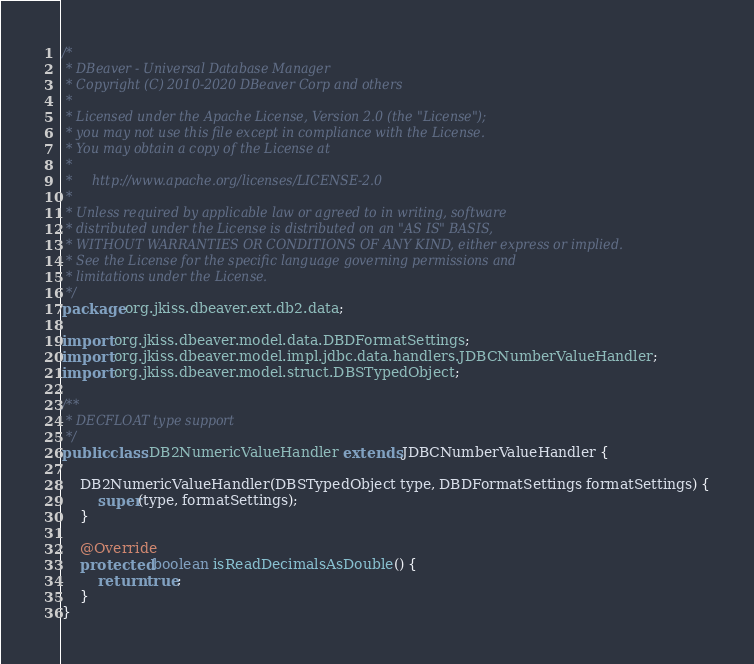Convert code to text. <code><loc_0><loc_0><loc_500><loc_500><_Java_>/*
 * DBeaver - Universal Database Manager
 * Copyright (C) 2010-2020 DBeaver Corp and others
 *
 * Licensed under the Apache License, Version 2.0 (the "License");
 * you may not use this file except in compliance with the License.
 * You may obtain a copy of the License at
 *
 *     http://www.apache.org/licenses/LICENSE-2.0
 *
 * Unless required by applicable law or agreed to in writing, software
 * distributed under the License is distributed on an "AS IS" BASIS,
 * WITHOUT WARRANTIES OR CONDITIONS OF ANY KIND, either express or implied.
 * See the License for the specific language governing permissions and
 * limitations under the License.
 */
package org.jkiss.dbeaver.ext.db2.data;

import org.jkiss.dbeaver.model.data.DBDFormatSettings;
import org.jkiss.dbeaver.model.impl.jdbc.data.handlers.JDBCNumberValueHandler;
import org.jkiss.dbeaver.model.struct.DBSTypedObject;

/**
 * DECFLOAT type support
 */
public class DB2NumericValueHandler extends JDBCNumberValueHandler {

    DB2NumericValueHandler(DBSTypedObject type, DBDFormatSettings formatSettings) {
        super(type, formatSettings);
    }

    @Override
    protected boolean isReadDecimalsAsDouble() {
        return true;
    }
}
</code> 